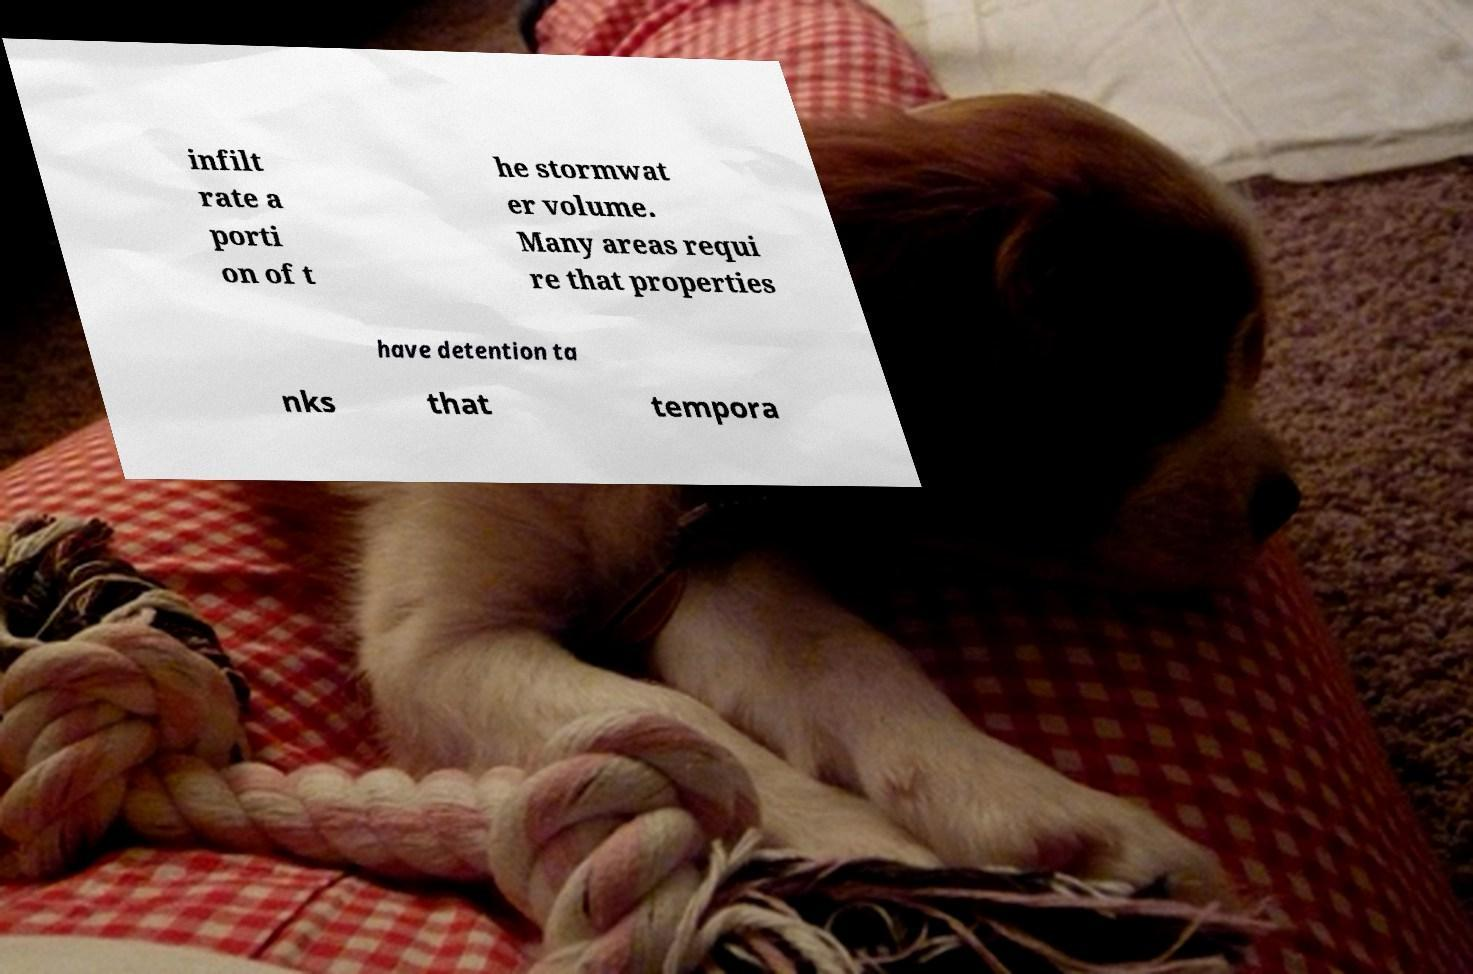Please read and relay the text visible in this image. What does it say? infilt rate a porti on of t he stormwat er volume. Many areas requi re that properties have detention ta nks that tempora 